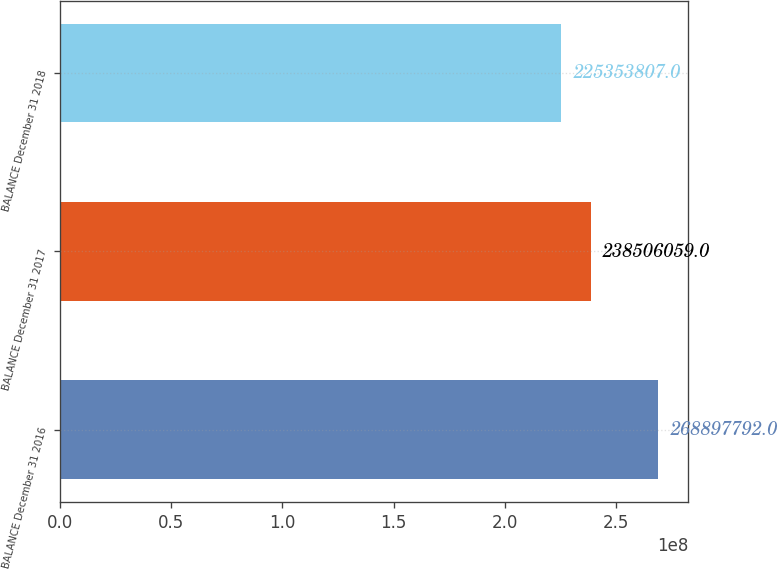<chart> <loc_0><loc_0><loc_500><loc_500><bar_chart><fcel>BALANCE December 31 2016<fcel>BALANCE December 31 2017<fcel>BALANCE December 31 2018<nl><fcel>2.68898e+08<fcel>2.38506e+08<fcel>2.25354e+08<nl></chart> 